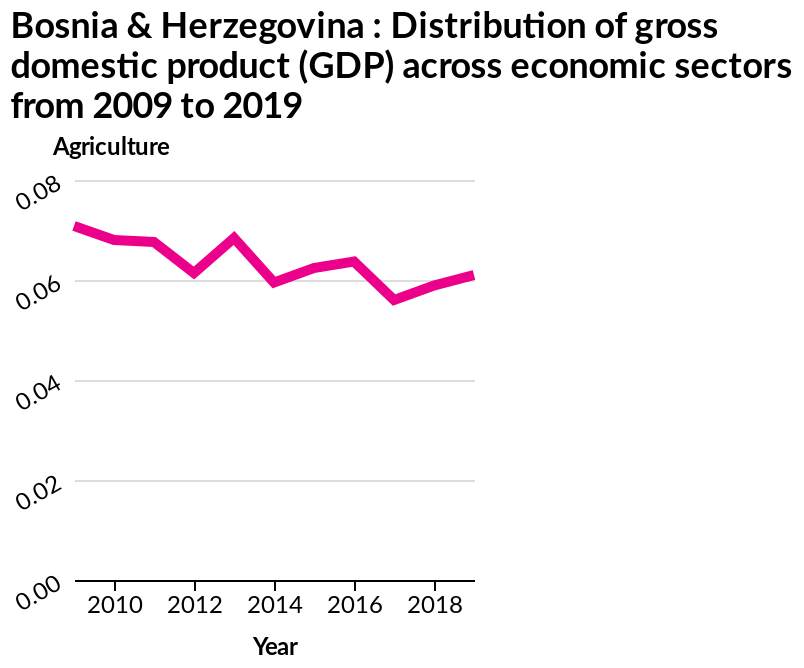<image>
What is the distribution of the gross domestic product (GDP) across economic sectors in Bosnia & Herzegovina?  The distribution of the gross domestic product (GDP) across economic sectors in Bosnia & Herzegovina is shown in a line chart from 2009 to 2019. please summary the statistics and relations of the chart The distribution of gross domestic product has declined from 2009 to 2019, however there are certain peaks such as in 2013 and 2016. What were the years when the distribution of gross domestic product peaked?  The distribution of gross domestic product peaked in 2013 and 2016. Is the line chart indicating any changes in the distribution of gross domestic product (GDP) across economic sectors over the years? Yes, the line chart shows the changes in the distribution of gross domestic product (GDP) across economic sectors over the years from 2009 to 2019. 